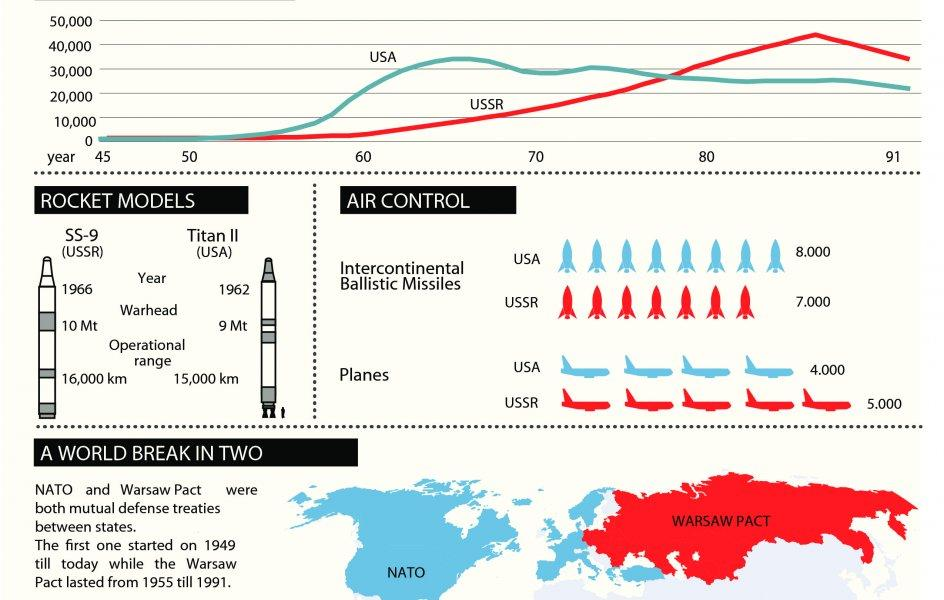Identify some key points in this picture. The Warsaw Pact was formed in 1955. The United States launched Titan II in 1962. The operational range of the SS-9 ballistic missile is approximately 16,000 kilometers. The Titan II warhead has a length of 9 megatons. The United States of America deployed 8,000 intercontinental ballistic missiles in NATO forces. 